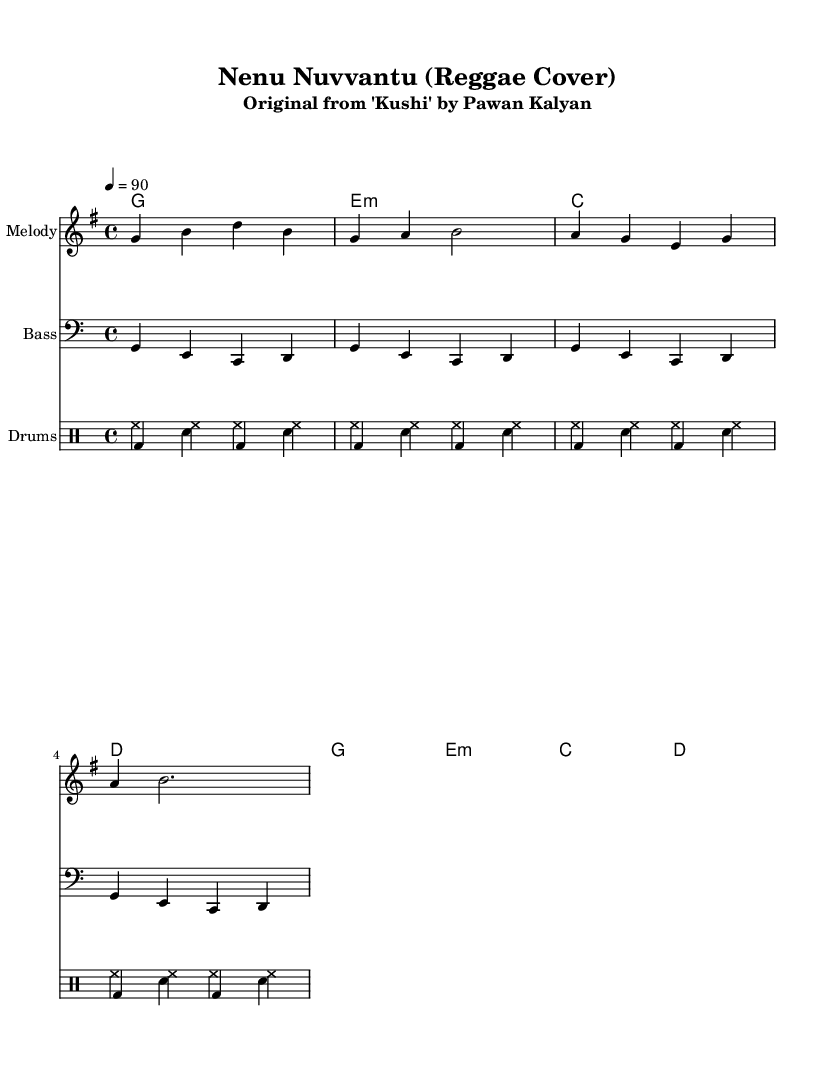What is the key signature of this music? The key signature is G major, indicated by one sharp (F#) in the key signature section.
Answer: G major What is the time signature of this piece? The time signature is 4/4, as seen at the beginning of the score, indicating four beats per measure.
Answer: 4/4 What is the tempo marking for this piece? The tempo marking is 90 beats per minute, shown in the tempo section as a quarter note equals 90.
Answer: 90 How many measures are in the melody section? The melody section has a total of 8 measures, as it consists of two groups of four measures each.
Answer: 8 What type of drums are used in this piece? The drum sections include hi-hat and bass drum specifically, as seen in the drum notation.
Answer: Hi-hat and bass drum What is the first chord in the chord progression? The first chord in the chord progression is G major, noted at the beginning of the chord section on the first measure.
Answer: G major How is the reggae rhythm characterized in this piece? The reggae rhythm is characterized by the offbeat hi-hat patterns and the bass drum accents in the drumming section, typical for reggae music.
Answer: Offbeat rhythm 